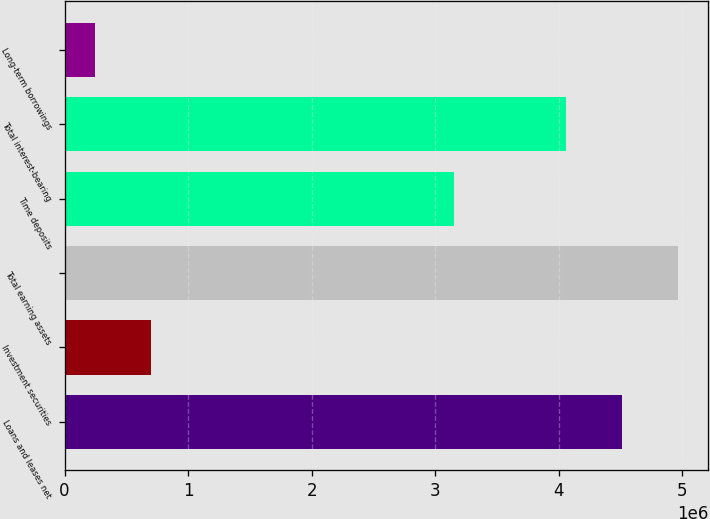Convert chart to OTSL. <chart><loc_0><loc_0><loc_500><loc_500><bar_chart><fcel>Loans and leases net<fcel>Investment securities<fcel>Total earning assets<fcel>Time deposits<fcel>Total interest-bearing<fcel>Long-term borrowings<nl><fcel>4.50989e+06<fcel>695973<fcel>4.96316e+06<fcel>3.15009e+06<fcel>4.05662e+06<fcel>242707<nl></chart> 